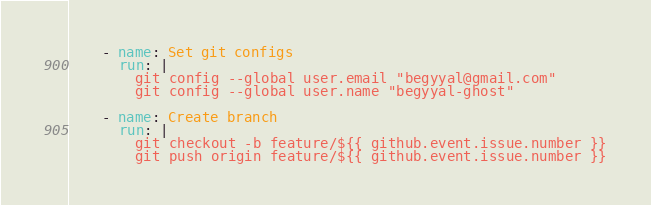<code> <loc_0><loc_0><loc_500><loc_500><_YAML_>
    - name: Set git configs
      run: |
        git config --global user.email "begyyal@gmail.com"
        git config --global user.name "begyyal-ghost"
    
    - name: Create branch
      run: |
        git checkout -b feature/${{ github.event.issue.number }}
        git push origin feature/${{ github.event.issue.number }}
</code> 